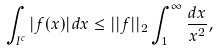<formula> <loc_0><loc_0><loc_500><loc_500>\int _ { I ^ { c } } | f ( x ) | d x \leq | | f | | _ { 2 } \int _ { 1 } ^ { \infty } \frac { d x } { x ^ { 2 } } ,</formula> 